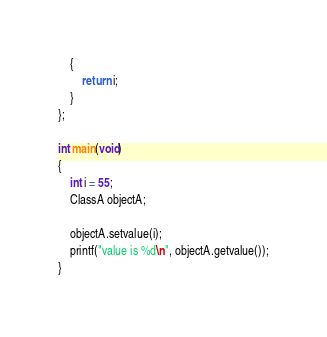Convert code to text. <code><loc_0><loc_0><loc_500><loc_500><_C++_>    {
        return i;
    }
};

int main(void)
{
    int i = 55;
    ClassA objectA;

    objectA.setvalue(i);
    printf("value is %d\n", objectA.getvalue());
}</code> 